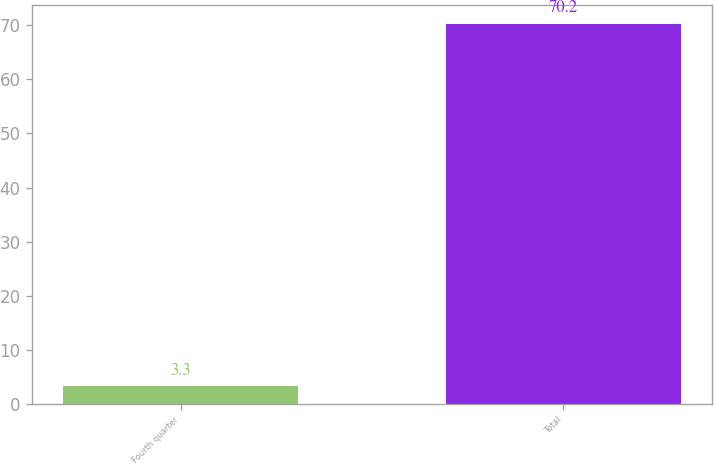<chart> <loc_0><loc_0><loc_500><loc_500><bar_chart><fcel>Fourth quarter<fcel>Total<nl><fcel>3.3<fcel>70.2<nl></chart> 